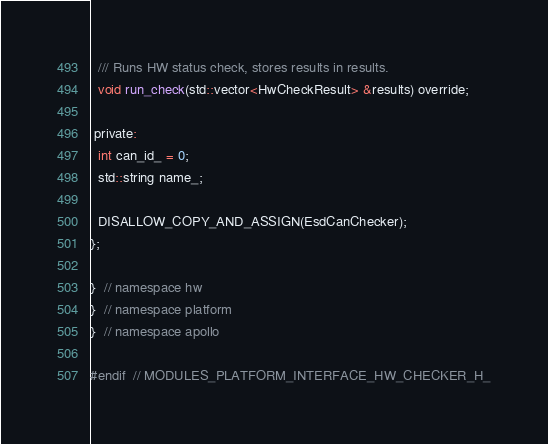Convert code to text. <code><loc_0><loc_0><loc_500><loc_500><_C_>  /// Runs HW status check, stores results in results.
  void run_check(std::vector<HwCheckResult> &results) override;

 private:
  int can_id_ = 0;
  std::string name_;

  DISALLOW_COPY_AND_ASSIGN(EsdCanChecker);
};

}  // namespace hw
}  // namespace platform
}  // namespace apollo

#endif  // MODULES_PLATFORM_INTERFACE_HW_CHECKER_H_
</code> 